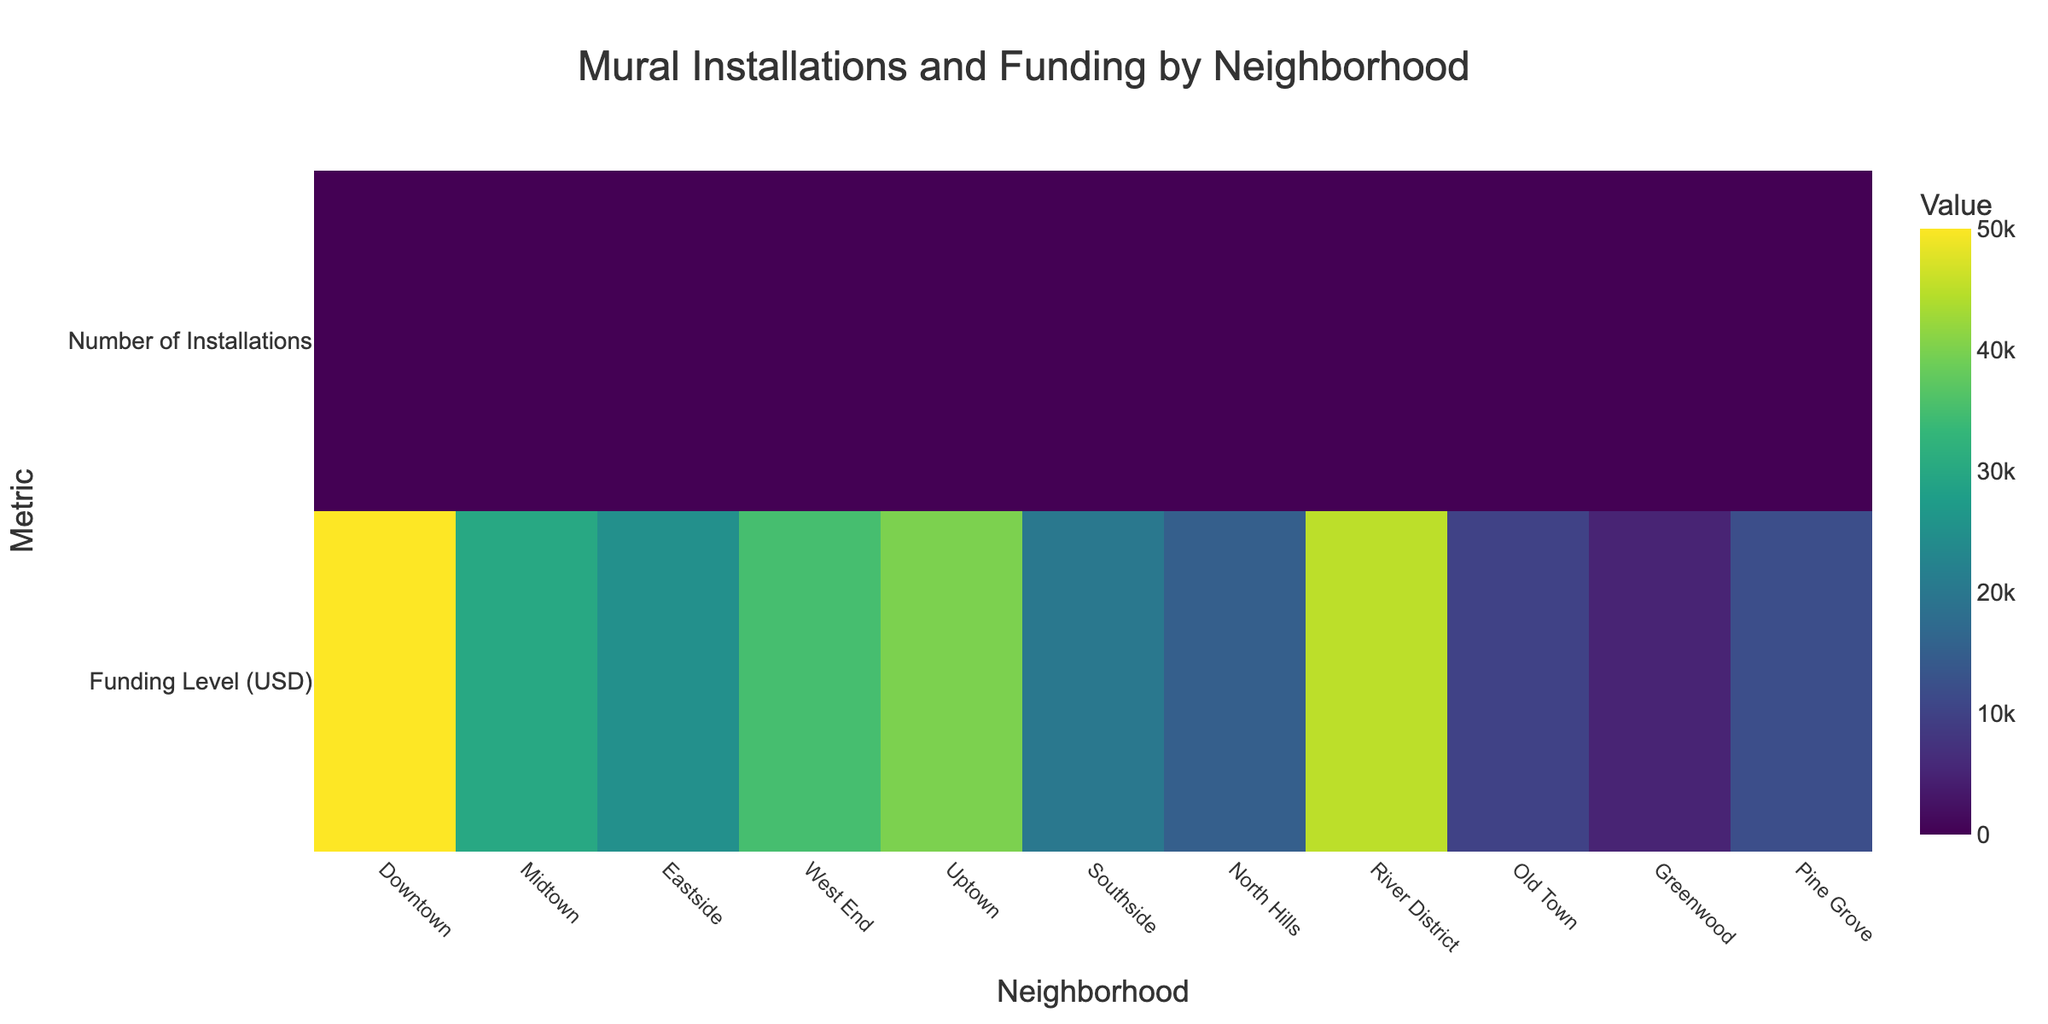What is the title of the figure? The title is located at the top center of the figure, usually in a larger and bold font. From the figure, the title reads "Mural Installations and Funding by Neighborhood".
Answer: Mural Installations and Funding by Neighborhood What are the metrics represented on the y-axis? The y-axis lists the metrics being analyzed. From the figure, the y-axis displays "Funding Level (USD)" and "Number of Installations".
Answer: Funding Level (USD) and Number of Installations Which neighborhood has the highest number of mural installations? By observing the "Number of Installations" row and looking for the highest value, we see that "River District" has the highest number of installations with a value of 16.
Answer: River District How many mural installations are there in Midtown? By locating "Midtown" along the x-axis and tracking it down to the "Number of Installations" row, the figure shows that Midtown has 10 installations.
Answer: 10 Compare the funding levels between Downtown and Southside. Which neighborhood received more funding and by how much? Looking at the "Funding Level (USD)" row, Downtown received $50,000 and Southside received $20,000. The difference between them is $50,000 - $20,000 = $30,000.
Answer: Downtown received more funding by $30,000 What is the sum of mural installations in the West End and Eastside neighborhoods? West End has 12 installations and Eastside has 8 installations. Adding them together gives 12 + 8 = 20.
Answer: 20 What is the average funding level among all the neighborhoods? Add up all the funding levels: $50,000 + $30,000 + $25,000 + $35,000 + $40,000 + $20,000 + $15,000 + $45,000 + $10,000 + $5,000 + $12,000 = $287,000. There are 11 neighborhoods, so the average funding level is $287,000 / 11 ≈ $26,090.91.
Answer: $26,090.91 Which neighborhoods have fewer than 10 mural installations? By examining the "Number of Installations" row, the neighborhoods with fewer than 10 installations are Southside (6), North Hills (5), Old Town (4), Greenwood (2), and Pine Grove (3).
Answer: Southside, North Hills, Old Town, Greenwood, Pine Grove Does a higher funding level generally correspond to a higher number of mural installations across neighborhoods? To answer this, observe the correlation between the "Funding Level (USD)" and "Number of Installations" rows for different neighborhoods. Generally, higher funding levels like in Downtown and River District do correspond to higher numbers of installations, but there are exceptions, such as Old Town (lower funding, fewer installations). This indicates a general trend but not a strict rule.
Answer: Generally yes, but with exceptions 